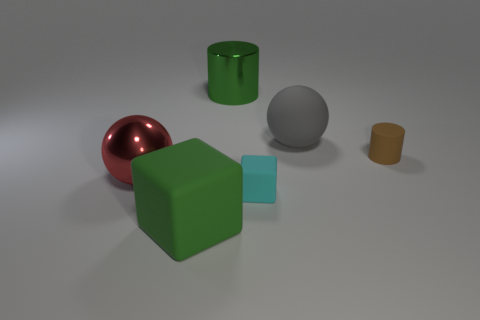Add 1 small cyan matte things. How many objects exist? 7 Subtract all cylinders. How many objects are left? 4 Subtract 1 cyan cubes. How many objects are left? 5 Subtract all tiny objects. Subtract all gray rubber balls. How many objects are left? 3 Add 3 large green things. How many large green things are left? 5 Add 3 brown shiny cylinders. How many brown shiny cylinders exist? 3 